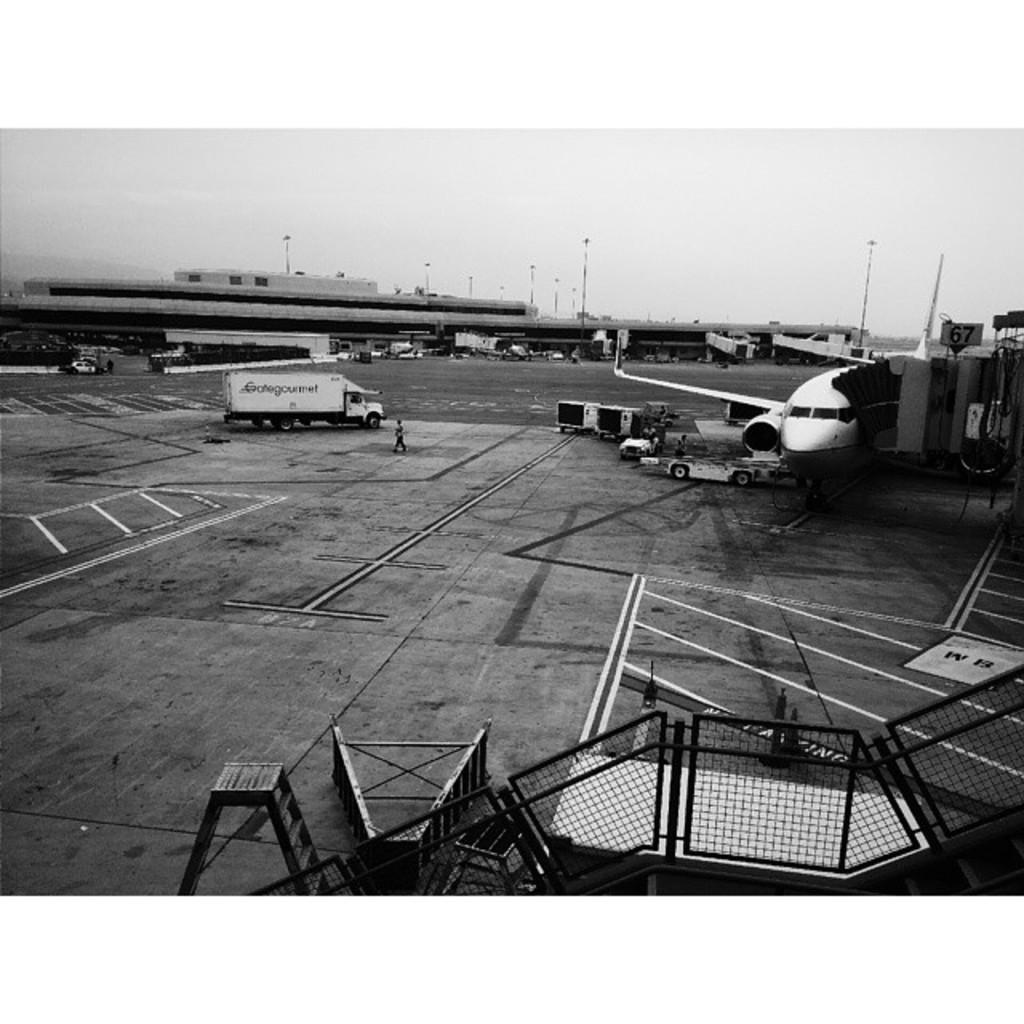In one or two sentences, can you explain what this image depicts? This is a black and white picture. In the middle of the picture, we see a vehicle. Beside that, we see a person is standing. At the bottom, we see the railing and the ladder stands. On the right side, we see an airplane. Beside that, we see the vehicles. In the background, we see a building and street lights. This picture might be clicked in the airport. 